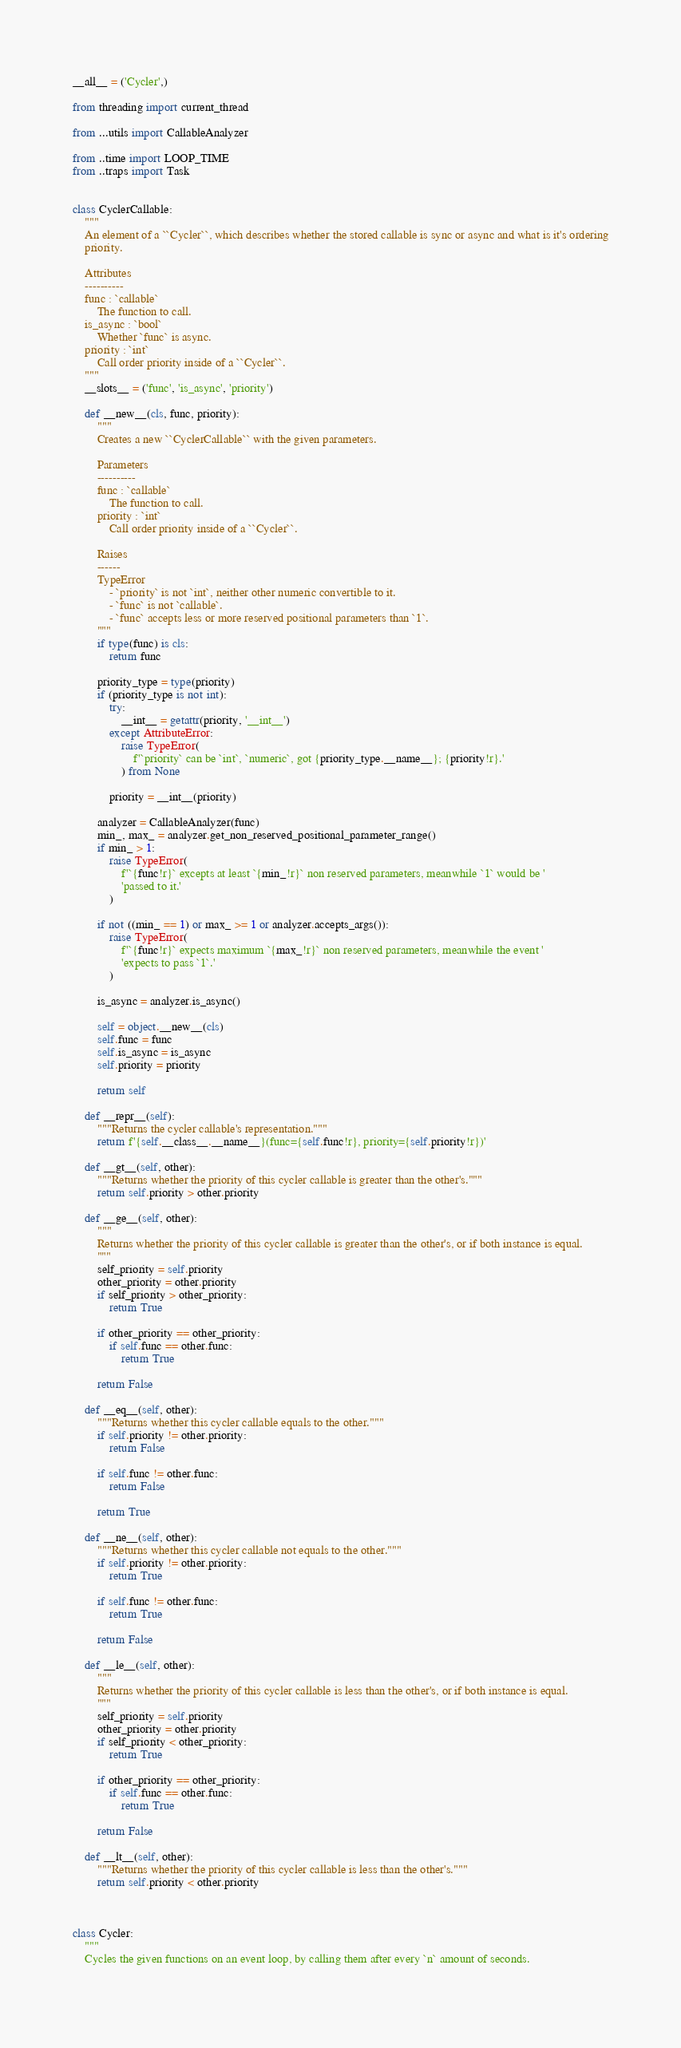<code> <loc_0><loc_0><loc_500><loc_500><_Python_>__all__ = ('Cycler',)

from threading import current_thread

from ...utils import CallableAnalyzer

from ..time import LOOP_TIME
from ..traps import Task


class CyclerCallable:
    """
    An element of a ``Cycler``, which describes whether the stored callable is sync or async and what is it's ordering
    priority.
    
    Attributes
    ----------
    func : `callable`
        The function to call.
    is_async : `bool`
        Whether `func` is async.
    priority : `int`
        Call order priority inside of a ``Cycler``.
    """
    __slots__ = ('func', 'is_async', 'priority')
    
    def __new__(cls, func, priority):
        """
        Creates a new ``CyclerCallable`` with the given parameters.
        
        Parameters
        ----------
        func : `callable`
            The function to call.
        priority : `int`
            Call order priority inside of a ``Cycler``.
        
        Raises
        ------
        TypeError
            - `priority` is not `int`, neither other numeric convertible to it.
            - `func` is not `callable`.
            - `func` accepts less or more reserved positional parameters than `1`.
        """
        if type(func) is cls:
            return func
        
        priority_type = type(priority)
        if (priority_type is not int):
            try:
                __int__ = getattr(priority, '__int__')
            except AttributeError:
                raise TypeError(
                    f'`priority` can be `int`, `numeric`, got {priority_type.__name__}; {priority!r}.'
                ) from None
            
            priority = __int__(priority)
        
        analyzer = CallableAnalyzer(func)
        min_, max_ = analyzer.get_non_reserved_positional_parameter_range()
        if min_ > 1:
            raise TypeError(
                f'`{func!r}` excepts at least `{min_!r}` non reserved parameters, meanwhile `1` would be '
                'passed to it.'
            )
        
        if not ((min_ == 1) or max_ >= 1 or analyzer.accepts_args()):
            raise TypeError(
                f'`{func!r}` expects maximum `{max_!r}` non reserved parameters, meanwhile the event '
                'expects to pass `1`.'
            )
        
        is_async = analyzer.is_async()
        
        self = object.__new__(cls)
        self.func = func
        self.is_async = is_async
        self.priority = priority
        
        return self
    
    def __repr__(self):
        """Returns the cycler callable's representation."""
        return f'{self.__class__.__name__}(func={self.func!r}, priority={self.priority!r})'
    
    def __gt__(self, other):
        """Returns whether the priority of this cycler callable is greater than the other's."""
        return self.priority > other.priority
    
    def __ge__(self, other):
        """
        Returns whether the priority of this cycler callable is greater than the other's, or if both instance is equal.
        """
        self_priority = self.priority
        other_priority = other.priority
        if self_priority > other_priority:
            return True
        
        if other_priority == other_priority:
            if self.func == other.func:
                return True
        
        return False
    
    def __eq__(self, other):
        """Returns whether this cycler callable equals to the other."""
        if self.priority != other.priority:
            return False
        
        if self.func != other.func:
            return False
        
        return True
    
    def __ne__(self, other):
        """Returns whether this cycler callable not equals to the other."""
        if self.priority != other.priority:
            return True
        
        if self.func != other.func:
            return True
        
        return False
    
    def __le__(self, other):
        """
        Returns whether the priority of this cycler callable is less than the other's, or if both instance is equal.
        """
        self_priority = self.priority
        other_priority = other.priority
        if self_priority < other_priority:
            return True
        
        if other_priority == other_priority:
            if self.func == other.func:
                return True
        
        return False

    def __lt__(self, other):
        """Returns whether the priority of this cycler callable is less than the other's."""
        return self.priority < other.priority



class Cycler:
    """
    Cycles the given functions on an event loop, by calling them after every `n` amount of seconds.
    </code> 